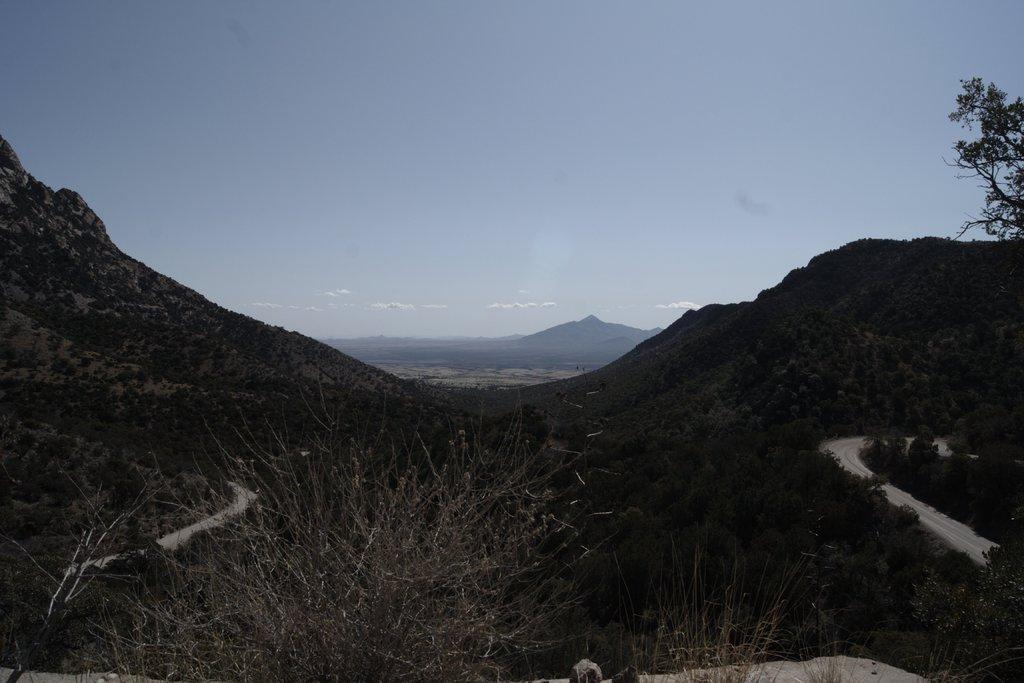What type of terrain is visible in the image? There are hills in the image. What other natural elements can be seen in the image? There are trees in the image. Is there any man-made infrastructure visible in the image? Yes, there is a road in the image. What is visible in the sky at the top of the image? Clouds are present in the sky at the top of the image. What type of rake is being used to experience the day in the image? There is no rake or experience of a day present in the image; it features hills, trees, a road, and clouds in the sky. 